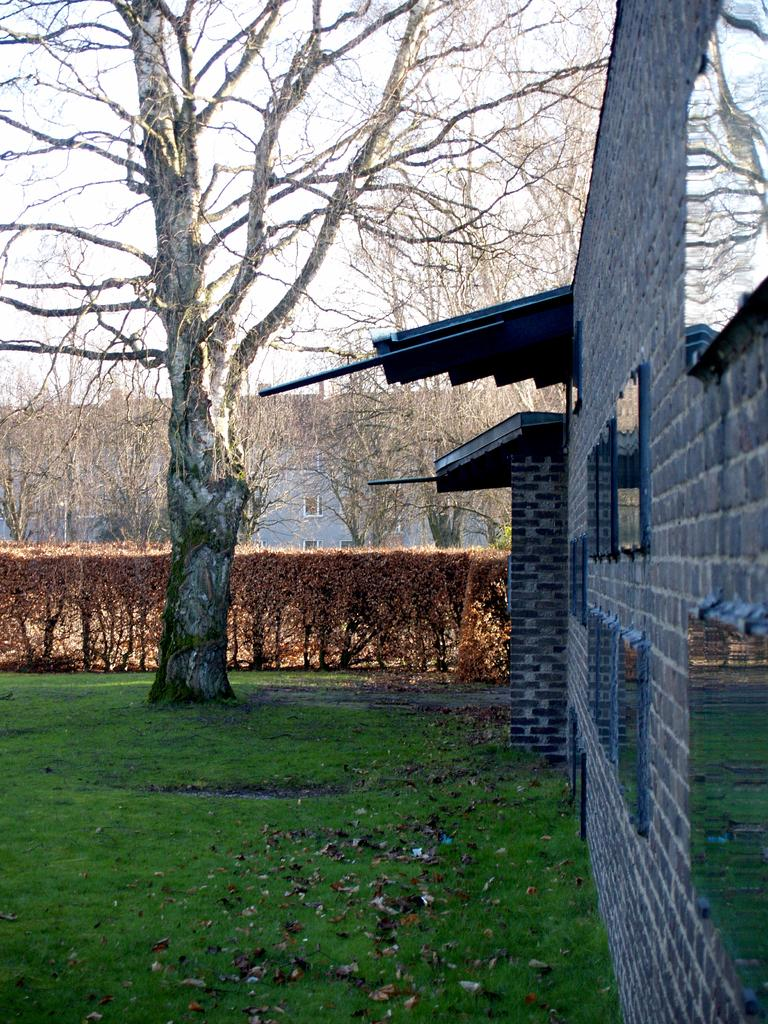What type of structures are visible in the image? There are houses in the image. What other natural elements can be seen in the image? There are trees and plants in the image. What is reflected in the windows of the houses? There are reflections of trees and grass in the windows. What is present on the ground in the image? There are leaves on the ground. What part of the environment is visible in the image? The sky is visible in the image. Can you hear the bell ringing in the image? There is no bell present in the image, so it cannot be heard. What is the uncle doing in the image? There is no uncle present in the image, so it cannot be determined what he might be doing. 